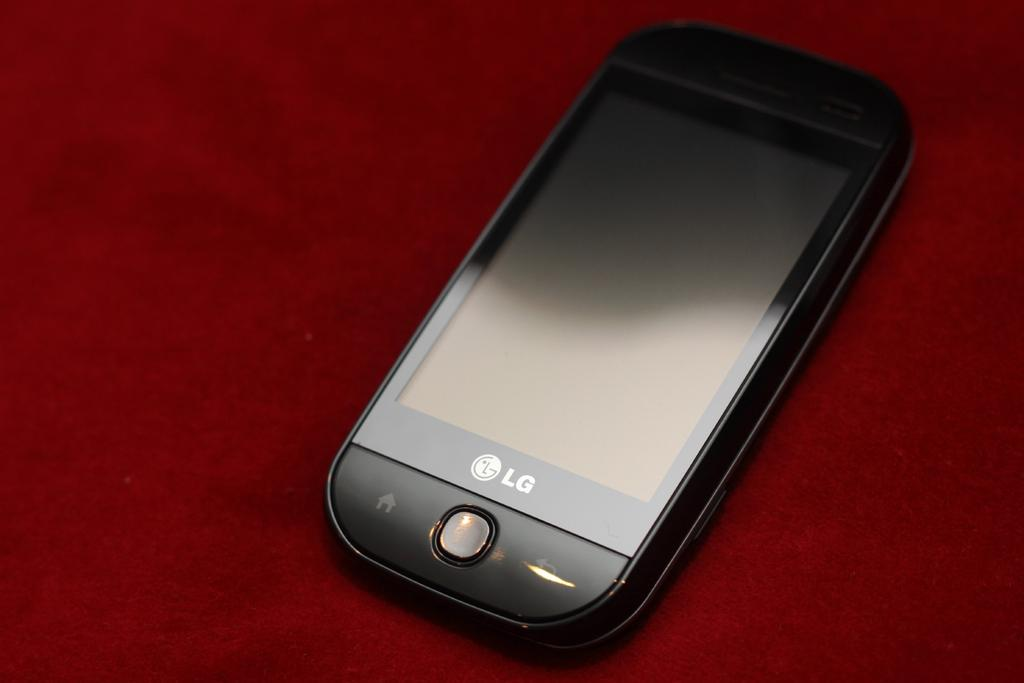<image>
Offer a succinct explanation of the picture presented. An LG smart phone rests on top of a red surface. 